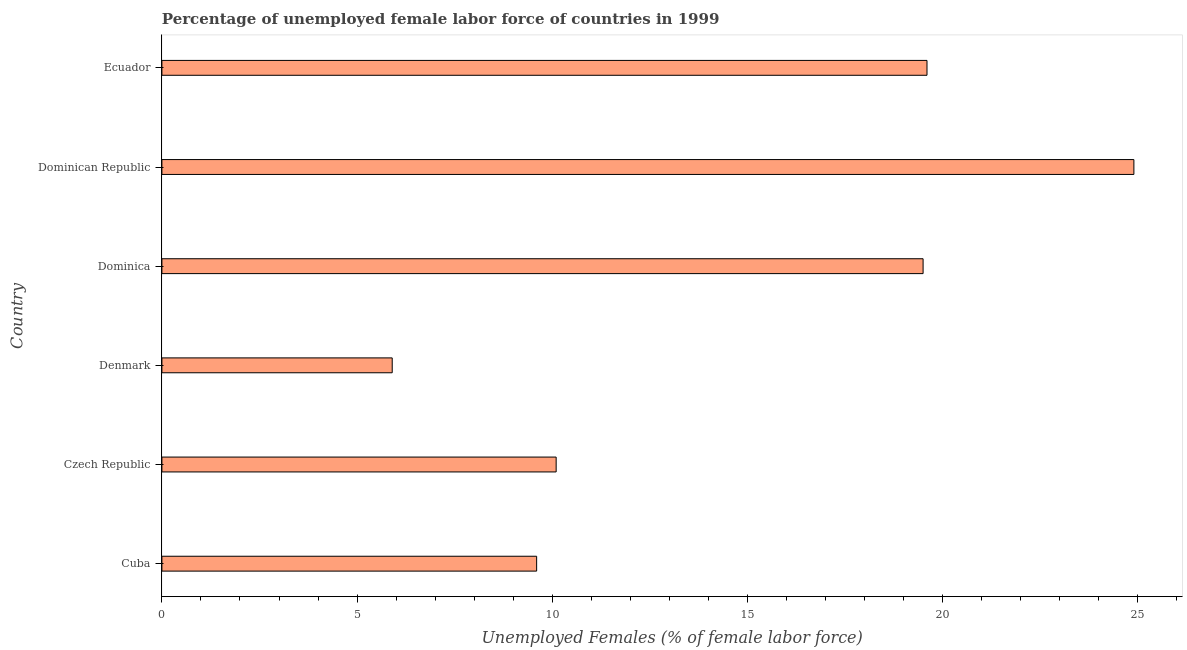Does the graph contain any zero values?
Keep it short and to the point. No. Does the graph contain grids?
Provide a short and direct response. No. What is the title of the graph?
Your response must be concise. Percentage of unemployed female labor force of countries in 1999. What is the label or title of the X-axis?
Your answer should be very brief. Unemployed Females (% of female labor force). What is the label or title of the Y-axis?
Offer a very short reply. Country. What is the total unemployed female labour force in Dominican Republic?
Ensure brevity in your answer.  24.9. Across all countries, what is the maximum total unemployed female labour force?
Make the answer very short. 24.9. Across all countries, what is the minimum total unemployed female labour force?
Ensure brevity in your answer.  5.9. In which country was the total unemployed female labour force maximum?
Offer a terse response. Dominican Republic. What is the sum of the total unemployed female labour force?
Your answer should be compact. 89.6. What is the average total unemployed female labour force per country?
Offer a terse response. 14.93. What is the median total unemployed female labour force?
Provide a succinct answer. 14.8. What is the ratio of the total unemployed female labour force in Cuba to that in Denmark?
Keep it short and to the point. 1.63. Is the difference between the total unemployed female labour force in Dominica and Ecuador greater than the difference between any two countries?
Give a very brief answer. No. What is the difference between the highest and the second highest total unemployed female labour force?
Give a very brief answer. 5.3. Is the sum of the total unemployed female labour force in Dominica and Ecuador greater than the maximum total unemployed female labour force across all countries?
Ensure brevity in your answer.  Yes. What is the difference between the highest and the lowest total unemployed female labour force?
Make the answer very short. 19. Are all the bars in the graph horizontal?
Offer a terse response. Yes. Are the values on the major ticks of X-axis written in scientific E-notation?
Keep it short and to the point. No. What is the Unemployed Females (% of female labor force) in Cuba?
Provide a short and direct response. 9.6. What is the Unemployed Females (% of female labor force) of Czech Republic?
Make the answer very short. 10.1. What is the Unemployed Females (% of female labor force) of Denmark?
Give a very brief answer. 5.9. What is the Unemployed Females (% of female labor force) of Dominica?
Provide a succinct answer. 19.5. What is the Unemployed Females (% of female labor force) of Dominican Republic?
Offer a terse response. 24.9. What is the Unemployed Females (% of female labor force) of Ecuador?
Your response must be concise. 19.6. What is the difference between the Unemployed Females (% of female labor force) in Cuba and Dominica?
Give a very brief answer. -9.9. What is the difference between the Unemployed Females (% of female labor force) in Cuba and Dominican Republic?
Offer a very short reply. -15.3. What is the difference between the Unemployed Females (% of female labor force) in Czech Republic and Denmark?
Your answer should be very brief. 4.2. What is the difference between the Unemployed Females (% of female labor force) in Czech Republic and Dominican Republic?
Make the answer very short. -14.8. What is the difference between the Unemployed Females (% of female labor force) in Denmark and Dominican Republic?
Offer a very short reply. -19. What is the difference between the Unemployed Females (% of female labor force) in Denmark and Ecuador?
Offer a terse response. -13.7. What is the difference between the Unemployed Females (% of female labor force) in Dominica and Dominican Republic?
Keep it short and to the point. -5.4. What is the ratio of the Unemployed Females (% of female labor force) in Cuba to that in Czech Republic?
Offer a terse response. 0.95. What is the ratio of the Unemployed Females (% of female labor force) in Cuba to that in Denmark?
Your answer should be compact. 1.63. What is the ratio of the Unemployed Females (% of female labor force) in Cuba to that in Dominica?
Your response must be concise. 0.49. What is the ratio of the Unemployed Females (% of female labor force) in Cuba to that in Dominican Republic?
Your response must be concise. 0.39. What is the ratio of the Unemployed Females (% of female labor force) in Cuba to that in Ecuador?
Provide a short and direct response. 0.49. What is the ratio of the Unemployed Females (% of female labor force) in Czech Republic to that in Denmark?
Your response must be concise. 1.71. What is the ratio of the Unemployed Females (% of female labor force) in Czech Republic to that in Dominica?
Your response must be concise. 0.52. What is the ratio of the Unemployed Females (% of female labor force) in Czech Republic to that in Dominican Republic?
Your answer should be compact. 0.41. What is the ratio of the Unemployed Females (% of female labor force) in Czech Republic to that in Ecuador?
Your response must be concise. 0.52. What is the ratio of the Unemployed Females (% of female labor force) in Denmark to that in Dominica?
Offer a very short reply. 0.3. What is the ratio of the Unemployed Females (% of female labor force) in Denmark to that in Dominican Republic?
Provide a short and direct response. 0.24. What is the ratio of the Unemployed Females (% of female labor force) in Denmark to that in Ecuador?
Keep it short and to the point. 0.3. What is the ratio of the Unemployed Females (% of female labor force) in Dominica to that in Dominican Republic?
Keep it short and to the point. 0.78. What is the ratio of the Unemployed Females (% of female labor force) in Dominican Republic to that in Ecuador?
Provide a succinct answer. 1.27. 